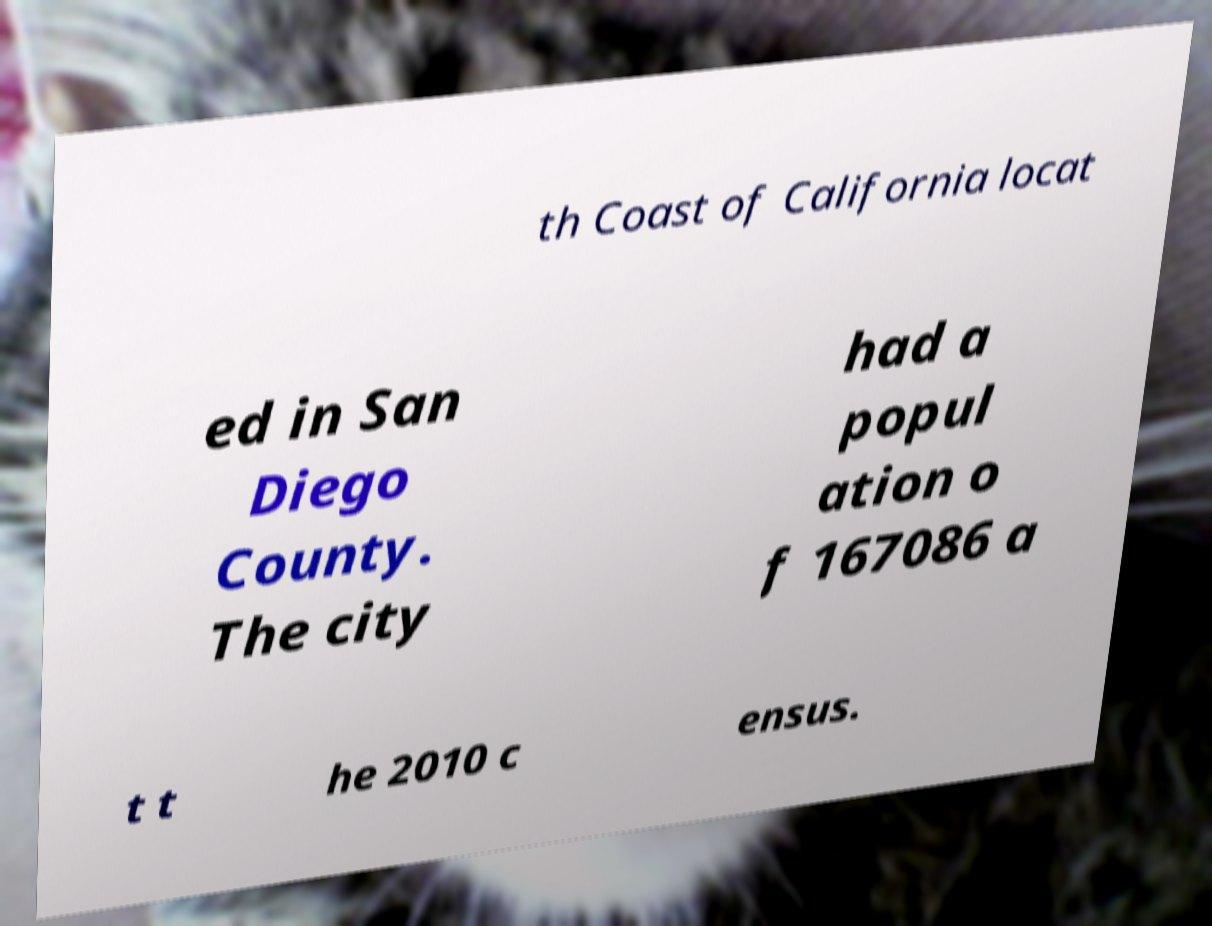For documentation purposes, I need the text within this image transcribed. Could you provide that? th Coast of California locat ed in San Diego County. The city had a popul ation o f 167086 a t t he 2010 c ensus. 